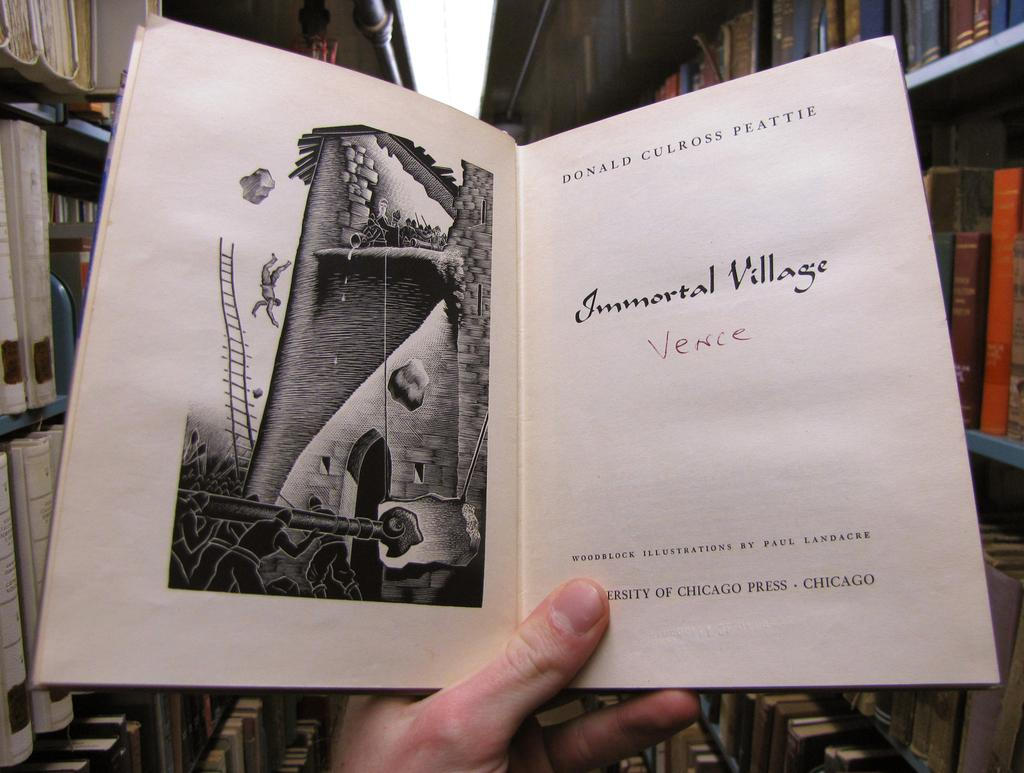<image>
Give a short and clear explanation of the subsequent image. A hand holds an open book entitled Immortal Village 